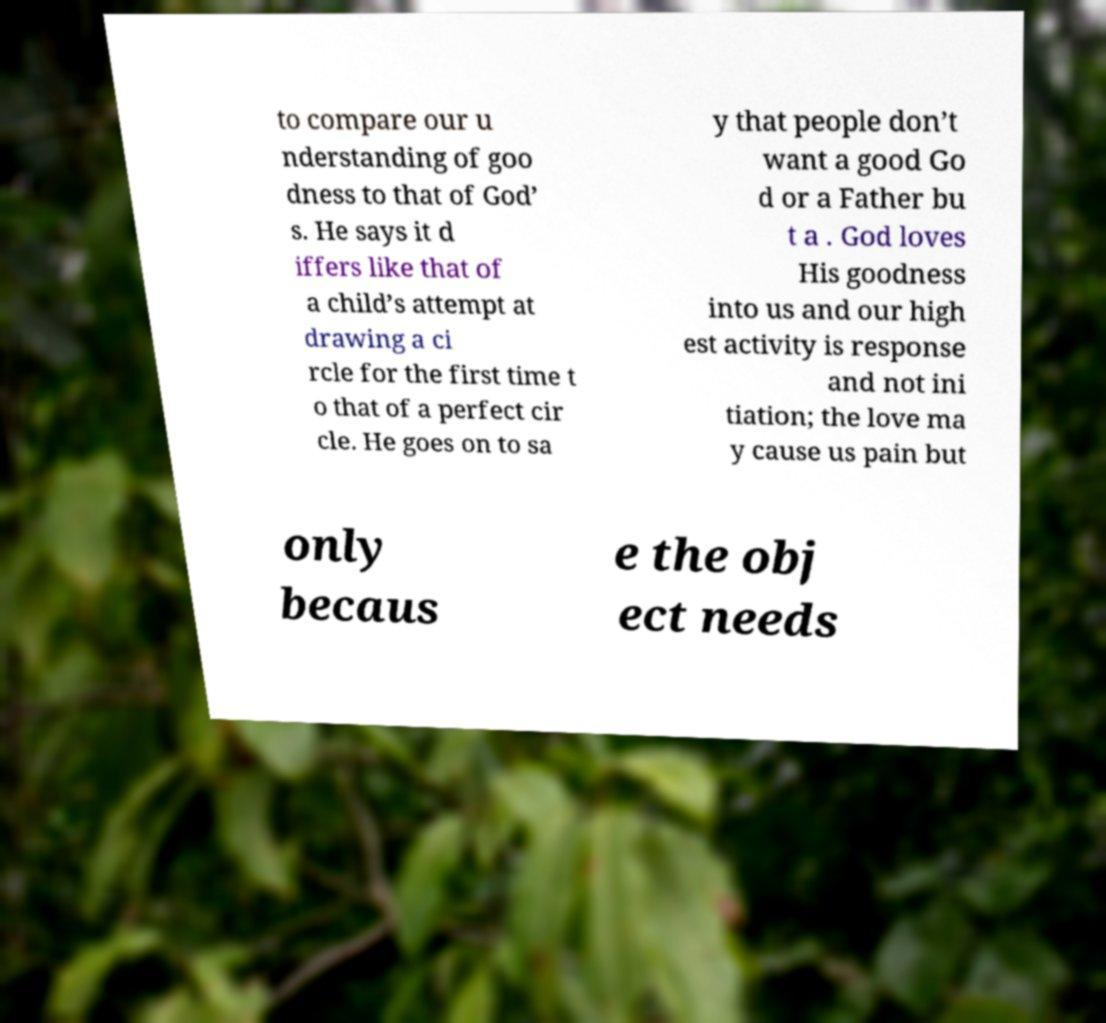Please read and relay the text visible in this image. What does it say? to compare our u nderstanding of goo dness to that of God’ s. He says it d iffers like that of a child’s attempt at drawing a ci rcle for the first time t o that of a perfect cir cle. He goes on to sa y that people don’t want a good Go d or a Father bu t a . God loves His goodness into us and our high est activity is response and not ini tiation; the love ma y cause us pain but only becaus e the obj ect needs 